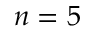Convert formula to latex. <formula><loc_0><loc_0><loc_500><loc_500>n = 5</formula> 